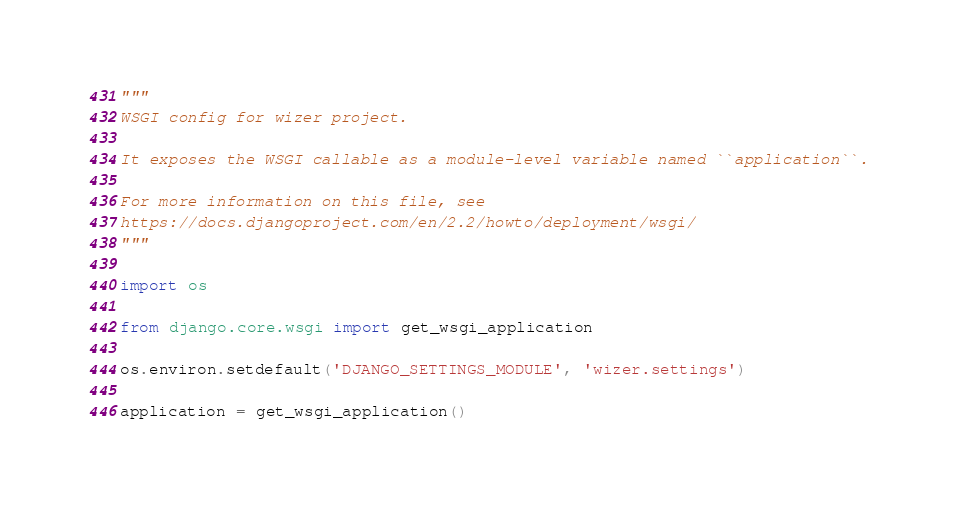<code> <loc_0><loc_0><loc_500><loc_500><_Python_>"""
WSGI config for wizer project.

It exposes the WSGI callable as a module-level variable named ``application``.

For more information on this file, see
https://docs.djangoproject.com/en/2.2/howto/deployment/wsgi/
"""

import os

from django.core.wsgi import get_wsgi_application

os.environ.setdefault('DJANGO_SETTINGS_MODULE', 'wizer.settings')

application = get_wsgi_application()
</code> 